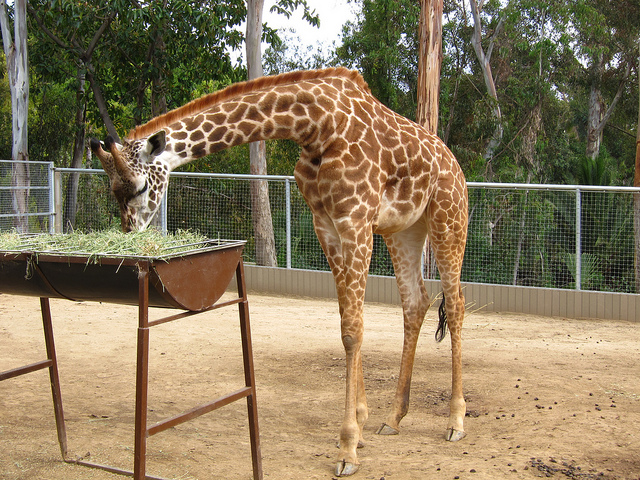What adaptations allow giraffes to reach their food? Giraffes have a number of adaptations for feeding, the most notable being their long necks and legs, allowing them to reach high branches. Their prehensile tongues, which can be up to 18 inches long, help them to pull leaves from trees. 